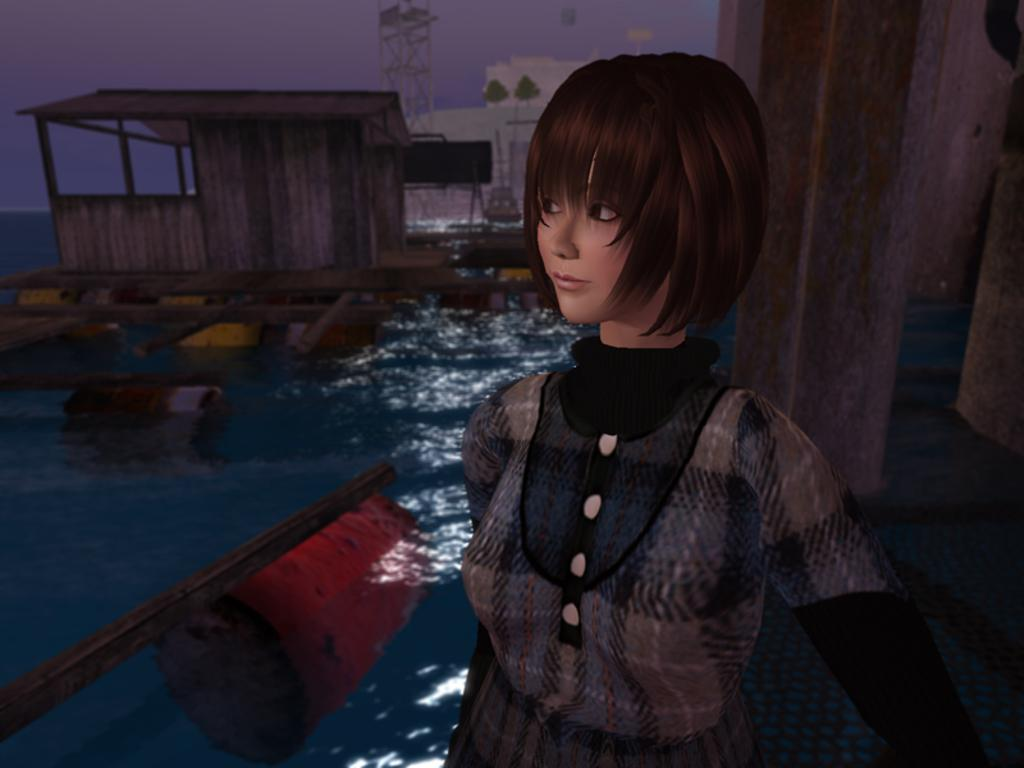What type of image is being described? The image is an animated image. Who or what can be seen in the image? There is a woman in the image. What is the primary element in the image? There is water in the image. What structures can be seen in the background of the image? There is a building, a shed, and a power tower in the background of the image. What else is visible in the background of the image? The sky is visible in the background of the image, along with some unspecified objects. What type of bait is being used by the woman in the image? There is no indication in the image that the woman is using any bait, as the image is animated and does not depict a fishing scenario. 